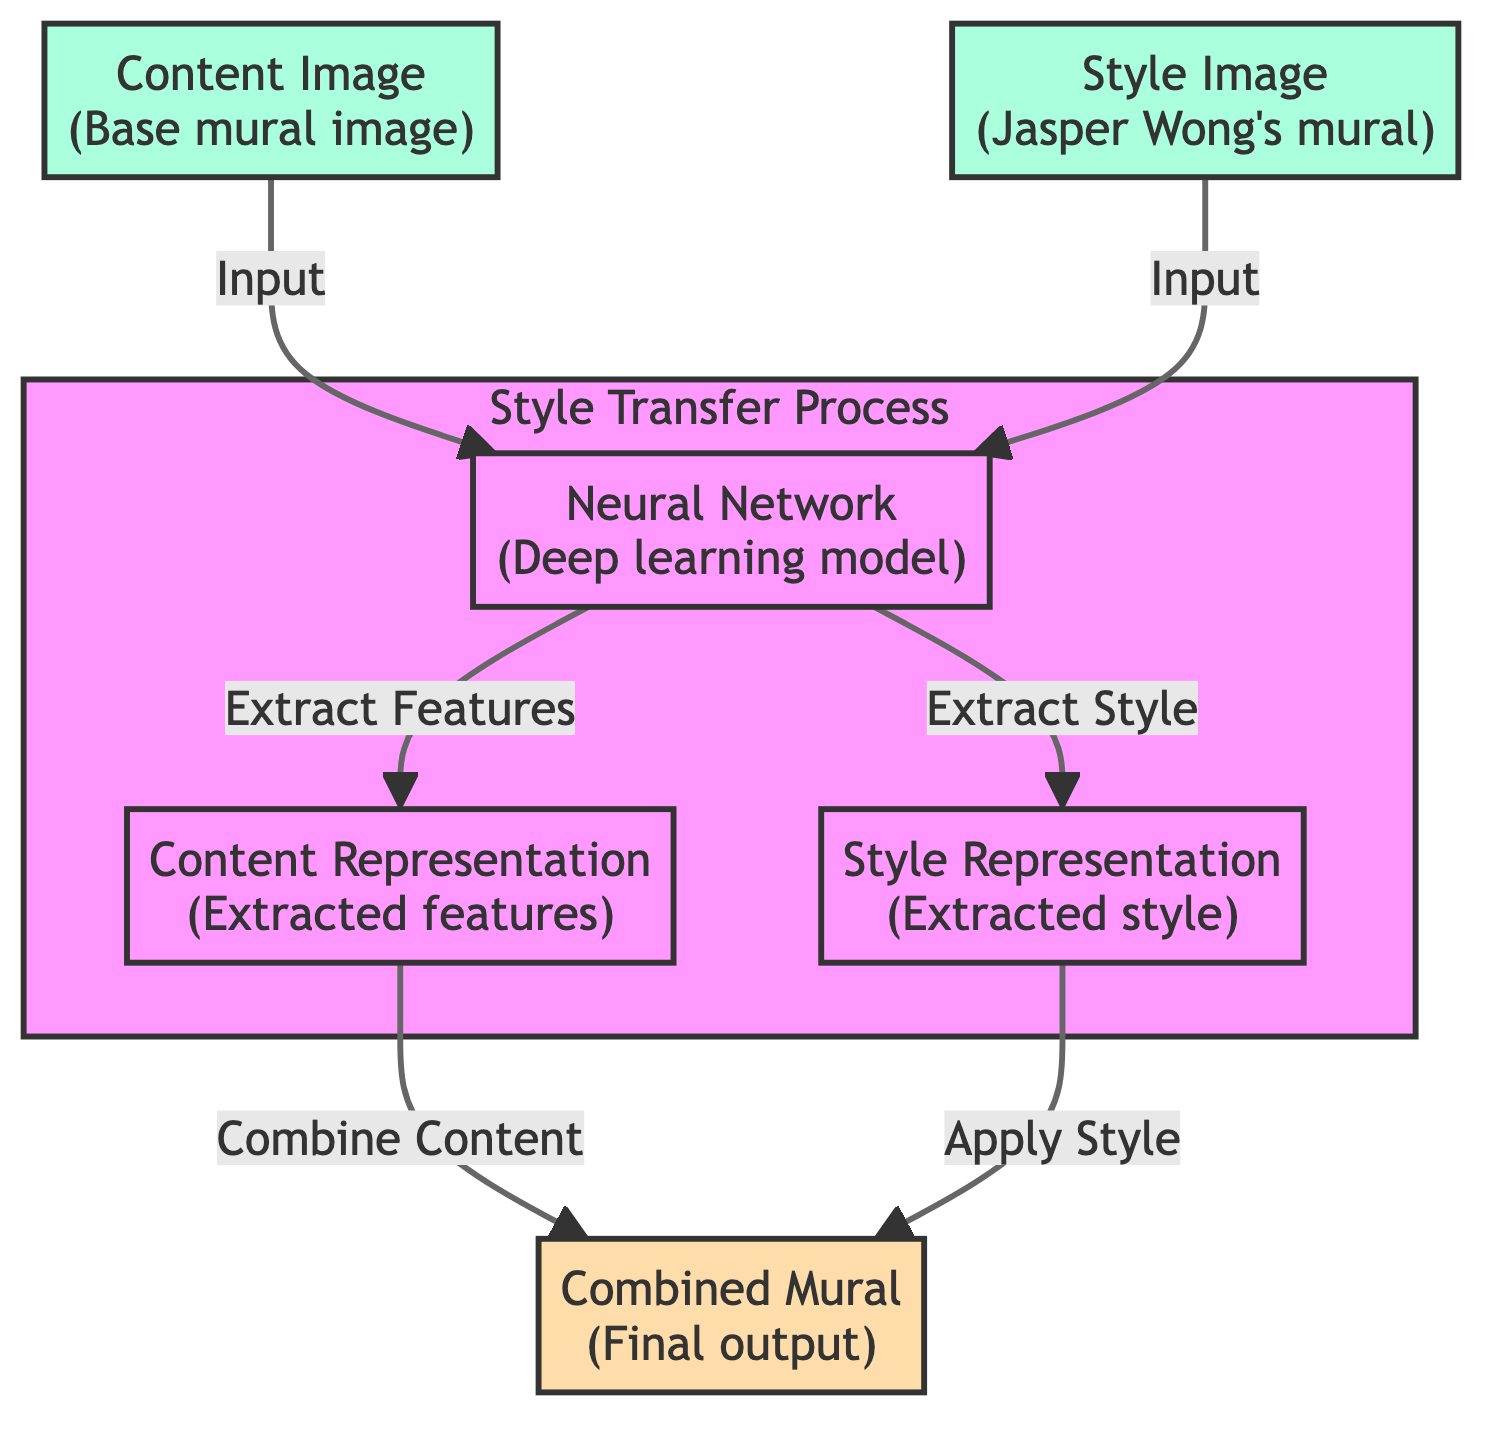What is the starting point of the style transfer process? The style transfer process starts with the input of the content image and style image, which are both represented as nodes in the diagram, leading into the neural network.
Answer: Content Image, Style Image How many representations are extracted in the neural network? In the diagram, the neural network extracts two representations: the content representation and the style representation, which are shown as separate nodes stemming from the neural network.
Answer: Two What is combined to create the final output mural? The final output mural is created by combining the content representation and the style representation, as indicated by the flow from each of these nodes into the combined mural node.
Answer: Content Representation, Style Representation What type of neural network is illustrated in this diagram? The diagram indicates that the neural network is a deep learning model which is explicitly mentioned in the node label for the neural network.
Answer: Deep learning model What do the arrows in the diagram indicate? The arrows in the diagram indicate the flow of information and the relationships between different stages of the style transfer process, showing how input images are processed and how the representations lead to the final output.
Answer: Flow of information What is the final output of the style transfer process? The final output of the process is a combined mural that integrates features from both the content and style images, as depicted in the output node labeled "Combined Mural".
Answer: Combined Mural Which node represents Jasper Wong's artistic style? The node labeled "Style Image" represents Jasper Wong's artistic style, specifically noting that it's his mural style that is being transferred onto the new designs.
Answer: Style Image How does the content representation influence the final mural? The content representation influences the final mural by being combined with the style representation, as indicated by the flow in the diagram that shows content representation contributing to the combined mural.
Answer: Combine Content What is the role of the neural network in this process? The neural network's role is to extract features from both the content and style images, processing each to provide the necessary representations for combining into the final output mural.
Answer: Extract Features, Extract Style 